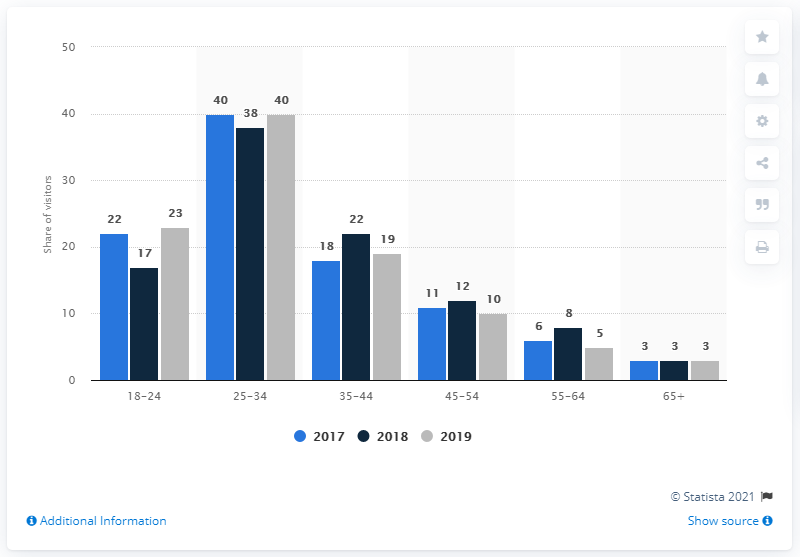Draw attention to some important aspects in this diagram. According to data from 2019, approximately 40% of visitors to Pornhub.com were between the ages of 25 and 34. 